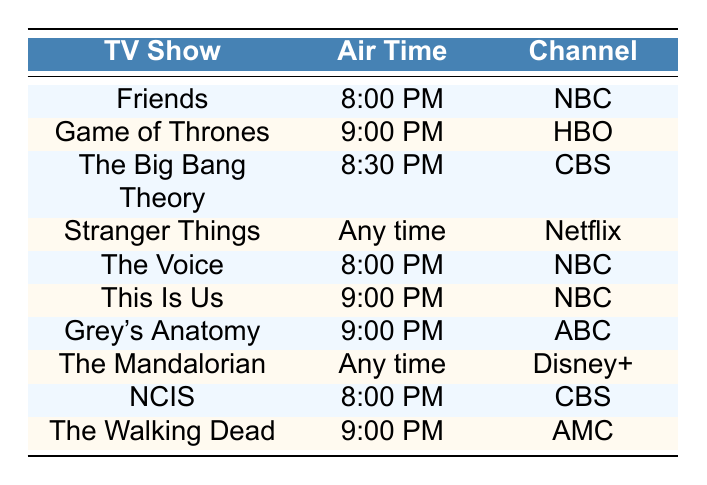What time does Friends air? Friends is listed in the table with the air time specified as 8:00 PM. You can find this information in the "Air Time" column corresponding to "Friends" in the "TV Show" column.
Answer: 8:00 PM Which channel broadcasts The Walking Dead? The table shows that The Walking Dead is listed under the "Channel" column as AMC. By locating The Walking Dead in the "TV Show" column, we find the corresponding channel in the same row.
Answer: AMC Are there any shows that air at 9:00 PM? Yes, the table lists three shows that have the air time of 9:00 PM: Game of Thrones, This Is Us, and Grey's Anatomy. Checking the "Air Time" column shows that they all match this time.
Answer: Yes Which TV show has the earliest air time? To find the earliest air time, we look at the air times listed in the table. Friends airs at 8:00 PM, and this is the earliest scheduled time among all shows that have specific air times. Both NCIS and The Voice also air at 8:00 PM, but Friends is the first in the list.
Answer: Friends, NCIS, The Voice How many shows are available to watch at any time? The table shows two shows, Stranger Things and The Mandalorian, that have "Any time" listed as their air time. We identify these by checking the air times in the table.
Answer: 2 Is there a TV show that airs on CBS at 8:00 PM? Yes, the table indicates that NCIS airs at 8:00 PM on CBS. This is found by looking for the "CBS" channel in the "Channel" column and checking the corresponding air time.
Answer: Yes Which channel has the most shows at 9:00 PM? The table indicates that NBC and ABC both have shows airing at 9:00 PM. NBC has two shows: This Is Us and the other show is Grey's Anatomy on ABC, so NBC has the most here. Thus, by counting the shows at this time, we find NBC has the most with two shows.
Answer: NBC Is there a TV show from HBO? Yes, the table lists Game of Thrones as airing on HBO. This is found by looking in the "Channel" column where HBO is listed next to Game of Thrones in the "TV Show" column.
Answer: Yes 